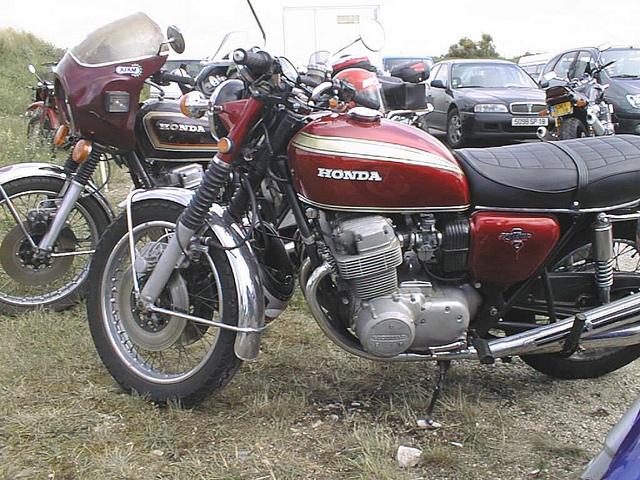Were these Honda motorcycles likely built in the last 5 years?
Short answer required. No. Are there any people?
Write a very short answer. No. How many motorcycles are there?
Short answer required. 3. 